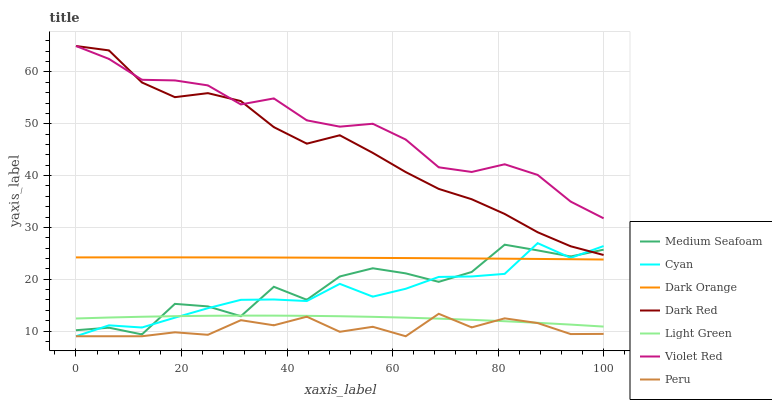Does Peru have the minimum area under the curve?
Answer yes or no. Yes. Does Violet Red have the maximum area under the curve?
Answer yes or no. Yes. Does Violet Red have the minimum area under the curve?
Answer yes or no. No. Does Peru have the maximum area under the curve?
Answer yes or no. No. Is Dark Orange the smoothest?
Answer yes or no. Yes. Is Medium Seafoam the roughest?
Answer yes or no. Yes. Is Violet Red the smoothest?
Answer yes or no. No. Is Violet Red the roughest?
Answer yes or no. No. Does Violet Red have the lowest value?
Answer yes or no. No. Does Dark Red have the highest value?
Answer yes or no. Yes. Does Peru have the highest value?
Answer yes or no. No. Is Peru less than Dark Orange?
Answer yes or no. Yes. Is Dark Red greater than Peru?
Answer yes or no. Yes. Does Medium Seafoam intersect Dark Red?
Answer yes or no. Yes. Is Medium Seafoam less than Dark Red?
Answer yes or no. No. Is Medium Seafoam greater than Dark Red?
Answer yes or no. No. Does Peru intersect Dark Orange?
Answer yes or no. No. 